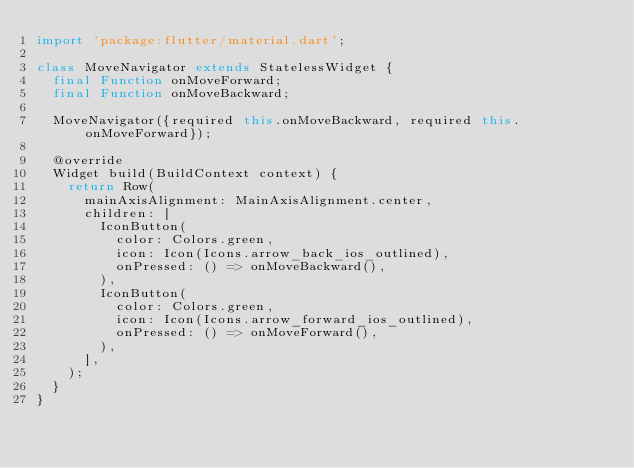Convert code to text. <code><loc_0><loc_0><loc_500><loc_500><_Dart_>import 'package:flutter/material.dart';

class MoveNavigator extends StatelessWidget {
  final Function onMoveForward;
  final Function onMoveBackward;

  MoveNavigator({required this.onMoveBackward, required this.onMoveForward});

  @override
  Widget build(BuildContext context) {
    return Row(
      mainAxisAlignment: MainAxisAlignment.center,
      children: [
        IconButton(
          color: Colors.green,
          icon: Icon(Icons.arrow_back_ios_outlined),
          onPressed: () => onMoveBackward(),
        ),
        IconButton(
          color: Colors.green,
          icon: Icon(Icons.arrow_forward_ios_outlined),
          onPressed: () => onMoveForward(),
        ),
      ],
    );
  }
}
</code> 